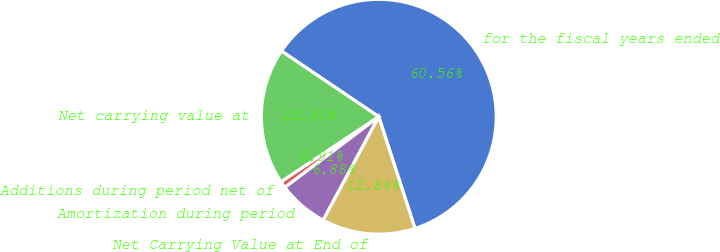<chart> <loc_0><loc_0><loc_500><loc_500><pie_chart><fcel>for the fiscal years ended<fcel>Net carrying value at<fcel>Additions during period net of<fcel>Amortization during period<fcel>Net Carrying Value at End of<nl><fcel>60.57%<fcel>18.81%<fcel>0.91%<fcel>6.88%<fcel>12.84%<nl></chart> 